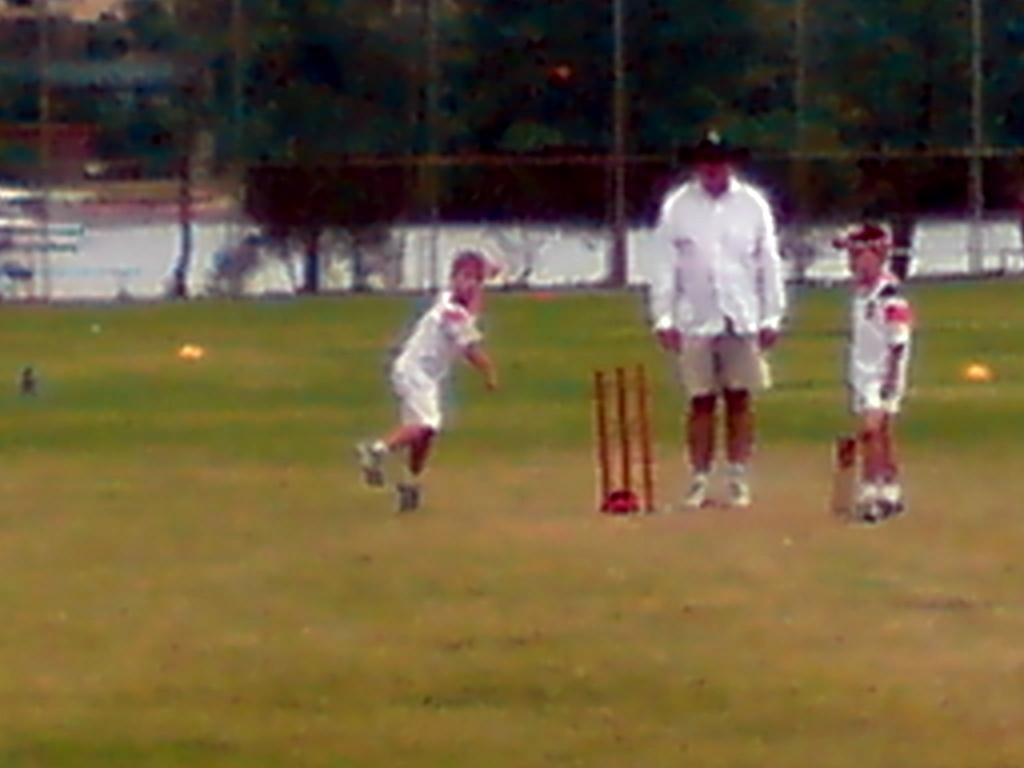Describe this image in one or two sentences. In the image there are two kids and one man standing on the ground. And also there are wickets. Behind them there is blur image with fencing and trees. 